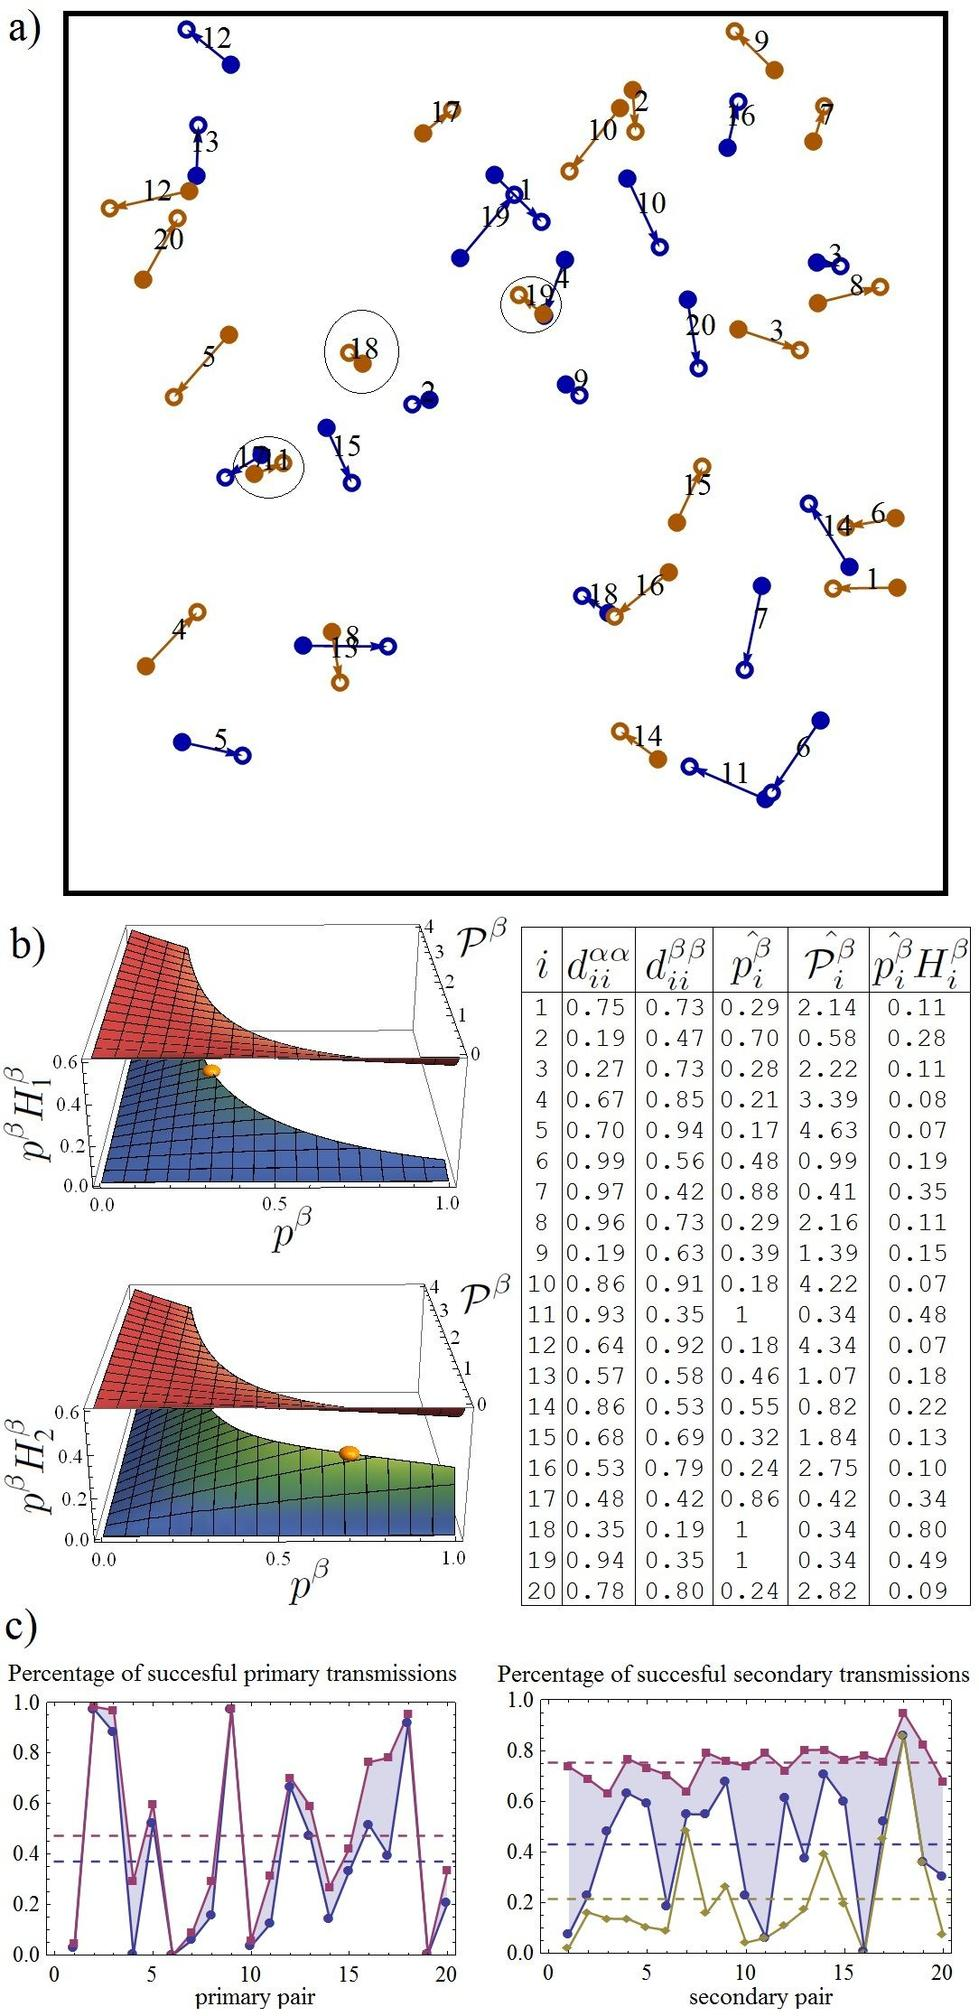Can you explain why node Q15 is isolated from nodes like Q11 and Q14 which are directly connected to each other? From the visualization in figure a), node Q15 appears isolated from Q11 and Q14 due to the absence of a direct linking line or path that connects them. This might suggest different group dynamics or sub-networks within the larger network where certain nodes only interact with specific others, optimizing certain types of information or resource flow. Considering this layout, nodes like Q15 may serve unique or specialized roles that do not require direct interaction with nodes focused on other tasks or functions. 